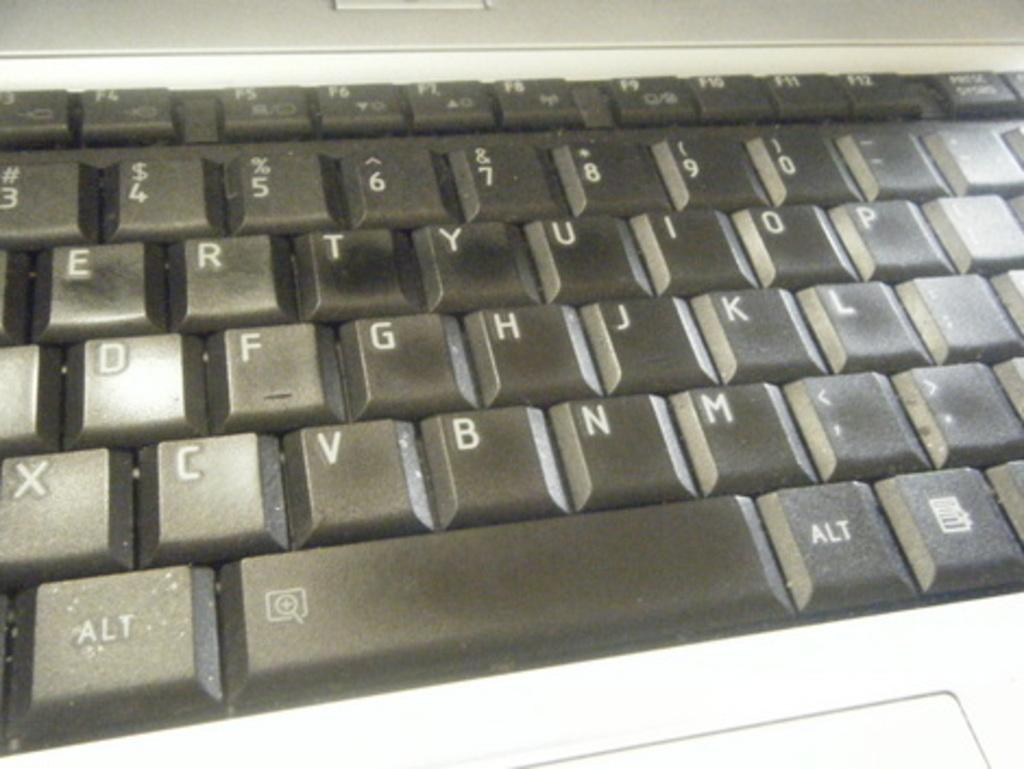<image>
Create a compact narrative representing the image presented. A black keyboard that shows some buttons like the alt key. 